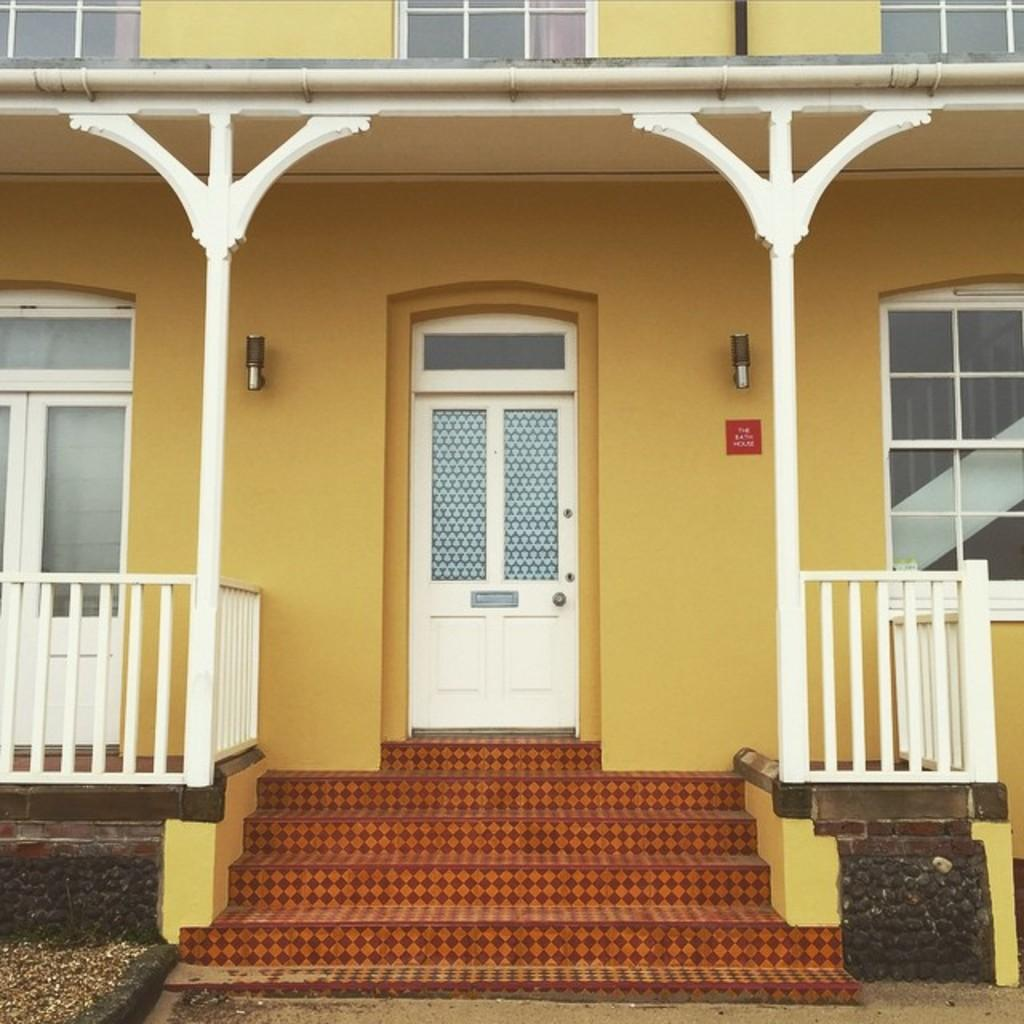What type of structure is visible in the image? There is a building in the image. What features can be seen on the building? The building has windows and a door. What is located in front of the building? There are steps in front of the building. Are there any additional architectural elements present? Yes, there is railing on both the left and right sides of the building. What type of music is being played by the girl on the roof of the building in the image? There is no girl or music present in the image; it only features a building with windows, a door, steps, and railings. 